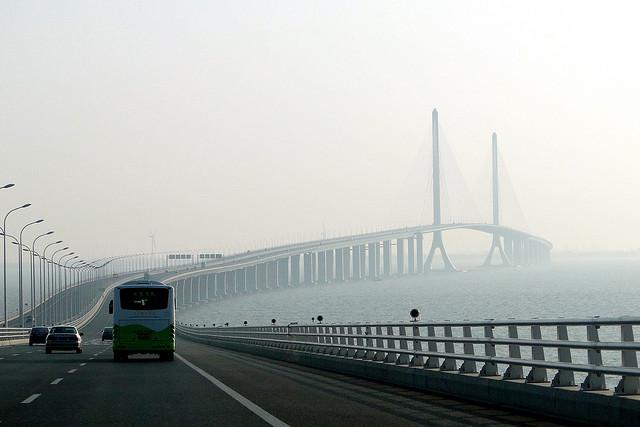Is it a clear day?
Write a very short answer. No. What time of year was this photo taken?
Answer briefly. Winter. Why are there wires above the trains?
Quick response, please. Bridge. Does THE BUS HAVE HEADLIGHTS ON?
Concise answer only. No. Is this photo pulling into a station?
Quick response, please. No. Is this a train?
Give a very brief answer. No. What type of vehicle has green on the bottom half?
Be succinct. Bus. Can these vehicles only follow a set path?
Answer briefly. Yes. Are the lights on or off?
Keep it brief. Off. Does this bridge have bumper-to-bumper traffic?
Write a very short answer. No. 